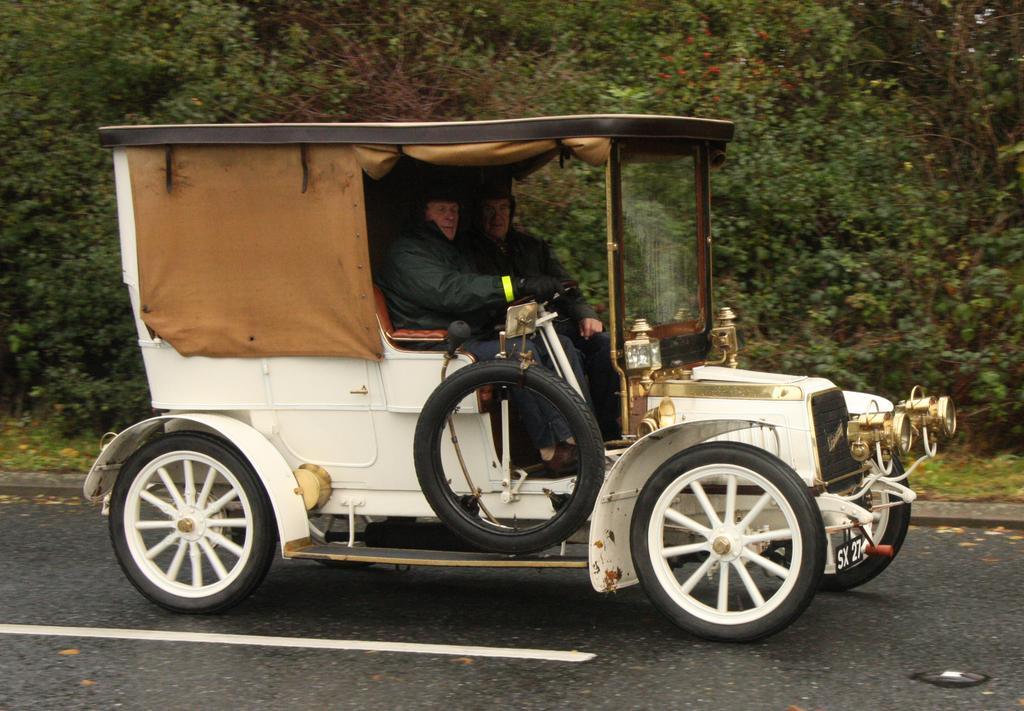How would you summarize this image in a sentence or two? In the picture we can see a vintage car with two people are sitting in and behind the car we can see the grass surface with many plants. 